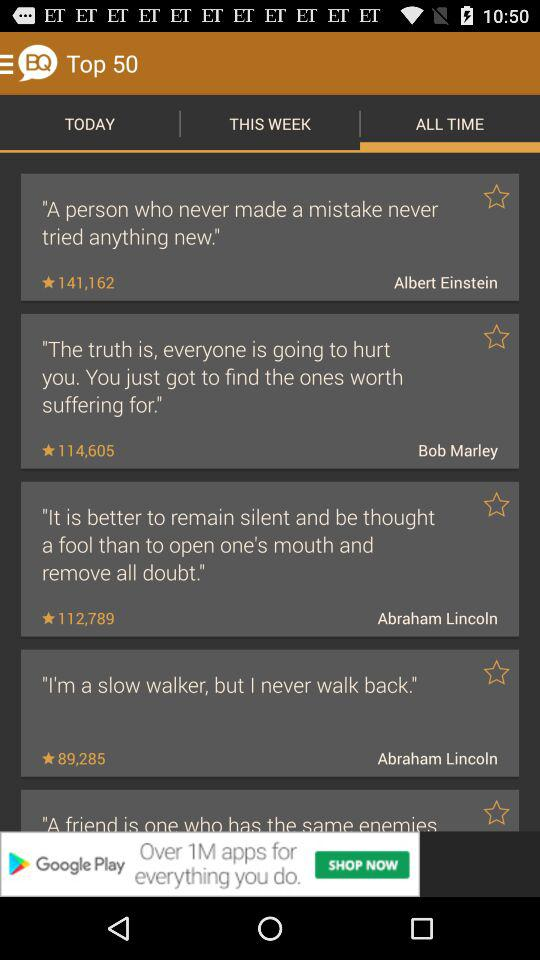Who wrote, "I'm a slow walker, but I never walk back."? "I'm a slow walker, but I never walk back." was written by Abraham Lincoln. 